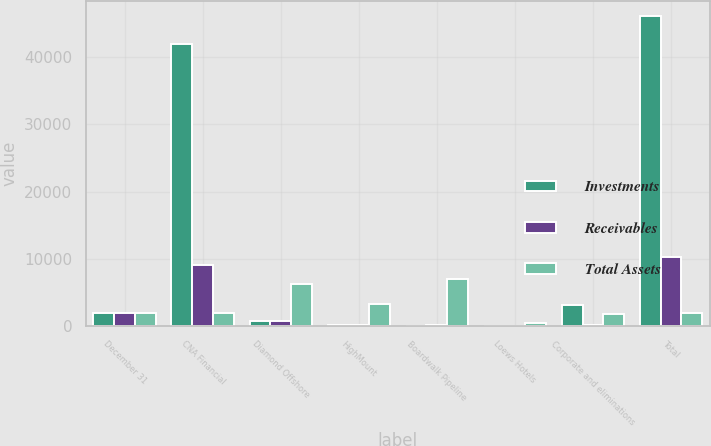Convert chart to OTSL. <chart><loc_0><loc_0><loc_500><loc_500><stacked_bar_chart><ecel><fcel>December 31<fcel>CNA Financial<fcel>Diamond Offshore<fcel>HighMount<fcel>Boardwalk Pipeline<fcel>Loews Hotels<fcel>Corporate and eliminations<fcel>Total<nl><fcel>Investments<fcel>2009<fcel>41996<fcel>739<fcel>80<fcel>46<fcel>61<fcel>3112<fcel>46034<nl><fcel>Receivables<fcel>2009<fcel>9104<fcel>794<fcel>97<fcel>110<fcel>27<fcel>80<fcel>10212<nl><fcel>Total Assets<fcel>2009<fcel>1935.5<fcel>6254<fcel>3225<fcel>7014<fcel>474<fcel>1862<fcel>1935.5<nl></chart> 